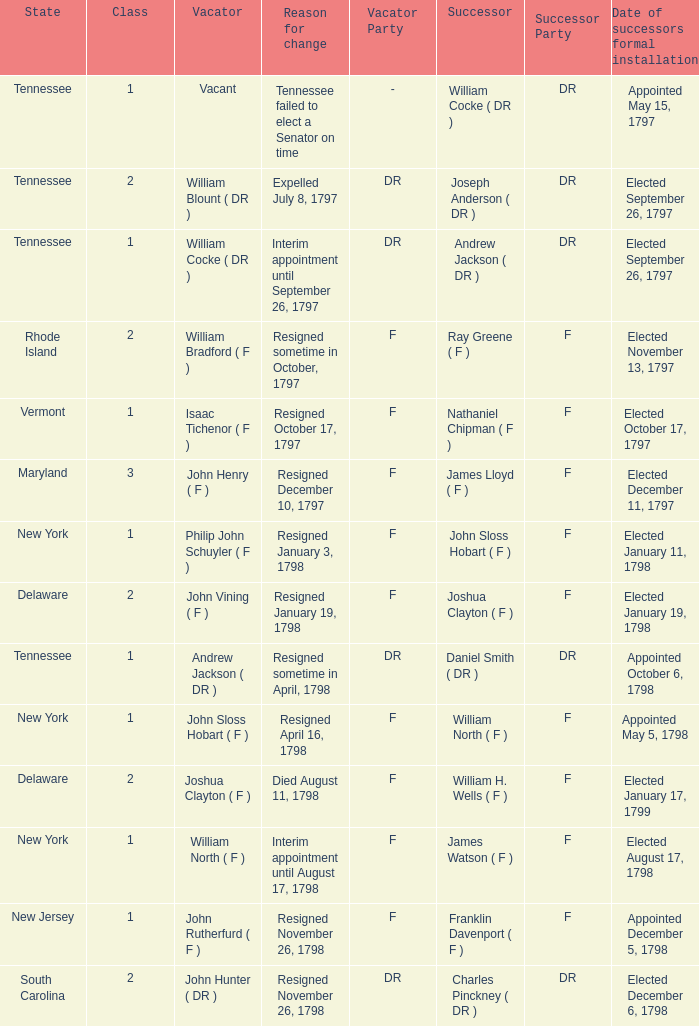What is the total number of dates of successor formal installation when the vacator was Joshua Clayton ( F )? 1.0. 